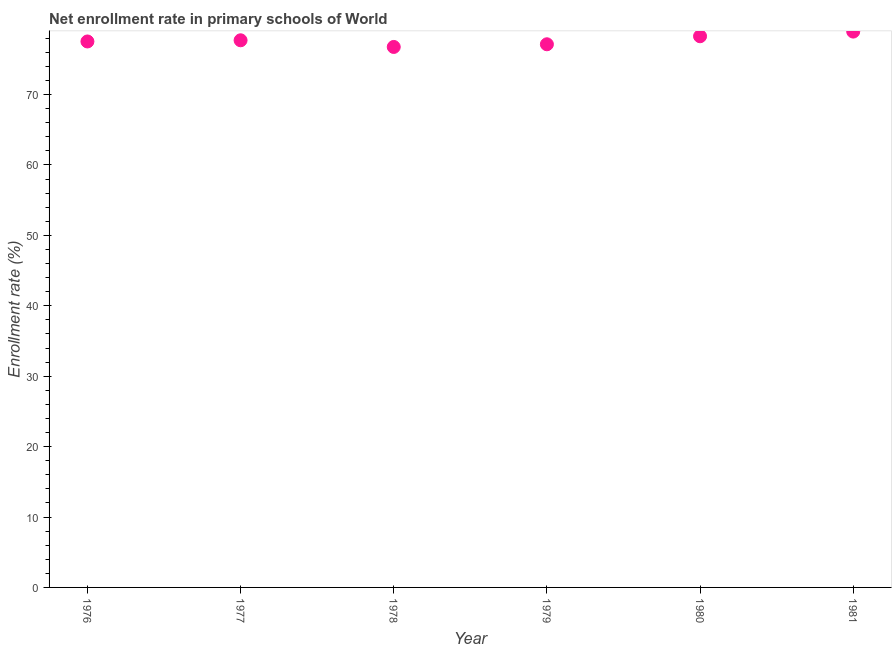What is the net enrollment rate in primary schools in 1980?
Keep it short and to the point. 78.28. Across all years, what is the maximum net enrollment rate in primary schools?
Give a very brief answer. 78.94. Across all years, what is the minimum net enrollment rate in primary schools?
Your answer should be compact. 76.76. In which year was the net enrollment rate in primary schools minimum?
Offer a very short reply. 1978. What is the sum of the net enrollment rate in primary schools?
Offer a very short reply. 466.37. What is the difference between the net enrollment rate in primary schools in 1977 and 1978?
Provide a succinct answer. 0.95. What is the average net enrollment rate in primary schools per year?
Offer a very short reply. 77.73. What is the median net enrollment rate in primary schools?
Your response must be concise. 77.62. Do a majority of the years between 1976 and 1978 (inclusive) have net enrollment rate in primary schools greater than 54 %?
Ensure brevity in your answer.  Yes. What is the ratio of the net enrollment rate in primary schools in 1976 to that in 1980?
Provide a short and direct response. 0.99. What is the difference between the highest and the second highest net enrollment rate in primary schools?
Provide a succinct answer. 0.66. Is the sum of the net enrollment rate in primary schools in 1976 and 1978 greater than the maximum net enrollment rate in primary schools across all years?
Ensure brevity in your answer.  Yes. What is the difference between the highest and the lowest net enrollment rate in primary schools?
Give a very brief answer. 2.18. How many dotlines are there?
Your response must be concise. 1. Does the graph contain grids?
Offer a very short reply. No. What is the title of the graph?
Provide a succinct answer. Net enrollment rate in primary schools of World. What is the label or title of the X-axis?
Your answer should be compact. Year. What is the label or title of the Y-axis?
Your answer should be very brief. Enrollment rate (%). What is the Enrollment rate (%) in 1976?
Make the answer very short. 77.54. What is the Enrollment rate (%) in 1977?
Your answer should be compact. 77.71. What is the Enrollment rate (%) in 1978?
Provide a succinct answer. 76.76. What is the Enrollment rate (%) in 1979?
Your answer should be compact. 77.14. What is the Enrollment rate (%) in 1980?
Give a very brief answer. 78.28. What is the Enrollment rate (%) in 1981?
Your answer should be very brief. 78.94. What is the difference between the Enrollment rate (%) in 1976 and 1977?
Your answer should be compact. -0.17. What is the difference between the Enrollment rate (%) in 1976 and 1978?
Keep it short and to the point. 0.78. What is the difference between the Enrollment rate (%) in 1976 and 1979?
Provide a succinct answer. 0.4. What is the difference between the Enrollment rate (%) in 1976 and 1980?
Ensure brevity in your answer.  -0.74. What is the difference between the Enrollment rate (%) in 1976 and 1981?
Offer a terse response. -1.4. What is the difference between the Enrollment rate (%) in 1977 and 1978?
Your response must be concise. 0.95. What is the difference between the Enrollment rate (%) in 1977 and 1979?
Offer a very short reply. 0.57. What is the difference between the Enrollment rate (%) in 1977 and 1980?
Keep it short and to the point. -0.57. What is the difference between the Enrollment rate (%) in 1977 and 1981?
Ensure brevity in your answer.  -1.23. What is the difference between the Enrollment rate (%) in 1978 and 1979?
Offer a terse response. -0.38. What is the difference between the Enrollment rate (%) in 1978 and 1980?
Keep it short and to the point. -1.52. What is the difference between the Enrollment rate (%) in 1978 and 1981?
Offer a terse response. -2.18. What is the difference between the Enrollment rate (%) in 1979 and 1980?
Provide a succinct answer. -1.14. What is the difference between the Enrollment rate (%) in 1979 and 1981?
Ensure brevity in your answer.  -1.8. What is the difference between the Enrollment rate (%) in 1980 and 1981?
Your answer should be compact. -0.66. What is the ratio of the Enrollment rate (%) in 1976 to that in 1979?
Ensure brevity in your answer.  1. What is the ratio of the Enrollment rate (%) in 1976 to that in 1980?
Keep it short and to the point. 0.99. What is the ratio of the Enrollment rate (%) in 1976 to that in 1981?
Make the answer very short. 0.98. What is the ratio of the Enrollment rate (%) in 1977 to that in 1978?
Provide a succinct answer. 1.01. What is the ratio of the Enrollment rate (%) in 1977 to that in 1980?
Offer a terse response. 0.99. What is the ratio of the Enrollment rate (%) in 1978 to that in 1980?
Make the answer very short. 0.98. What is the ratio of the Enrollment rate (%) in 1979 to that in 1981?
Ensure brevity in your answer.  0.98. 